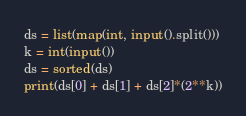<code> <loc_0><loc_0><loc_500><loc_500><_Python_>ds = list(map(int, input().split()))
k = int(input())
ds = sorted(ds)
print(ds[0] + ds[1] + ds[2]*(2**k))</code> 